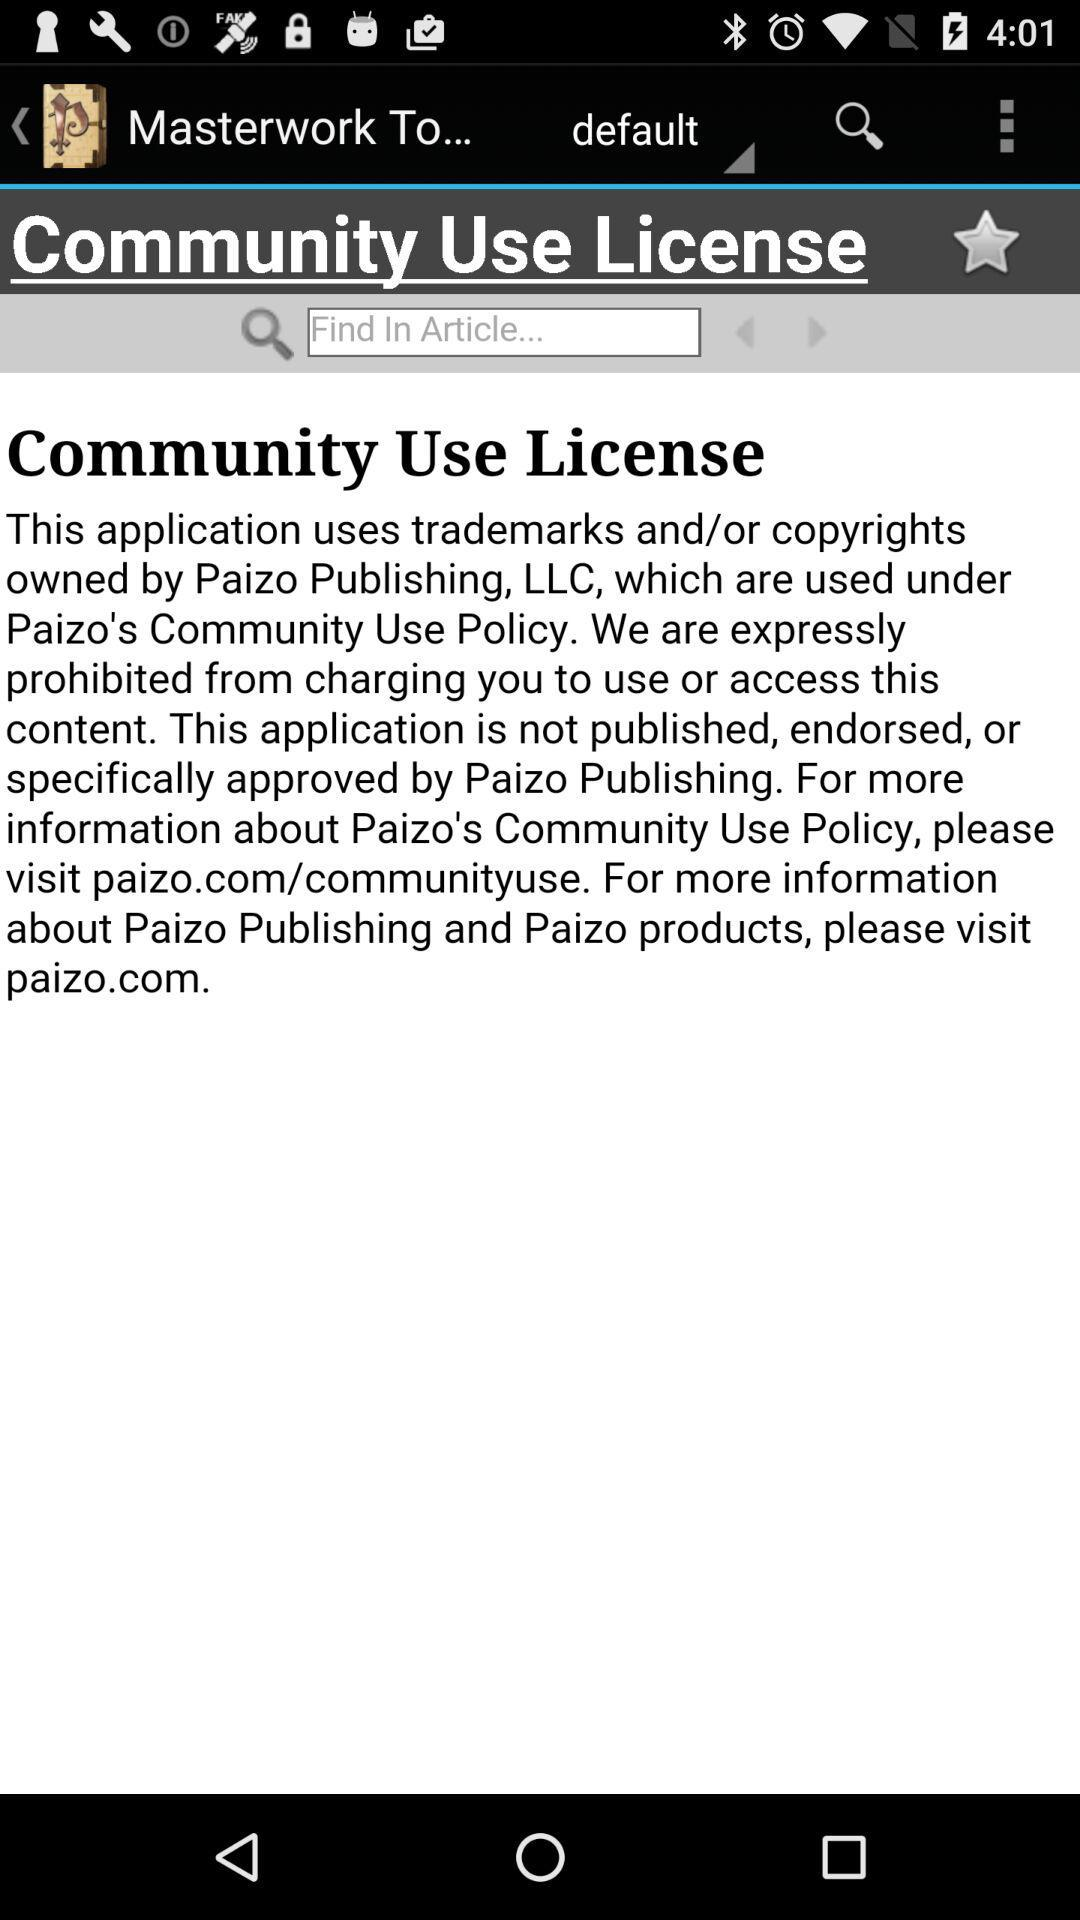What website can be visited for more information? The website that can be visited for more information is paizo.com. 